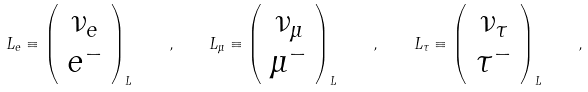Convert formula to latex. <formula><loc_0><loc_0><loc_500><loc_500>L _ { e } \equiv \left ( \begin{array} { c } \nu _ { e } \\ e ^ { - } \end{array} \right ) _ { L } \quad , \quad L _ { \mu } \equiv \left ( \begin{array} { c } \nu _ { \mu } \\ \mu ^ { - } \end{array} \right ) _ { L } \quad , \quad L _ { \tau } \equiv \left ( \begin{array} { c } \nu _ { \tau } \\ \tau ^ { - } \end{array} \right ) _ { L } \quad ,</formula> 